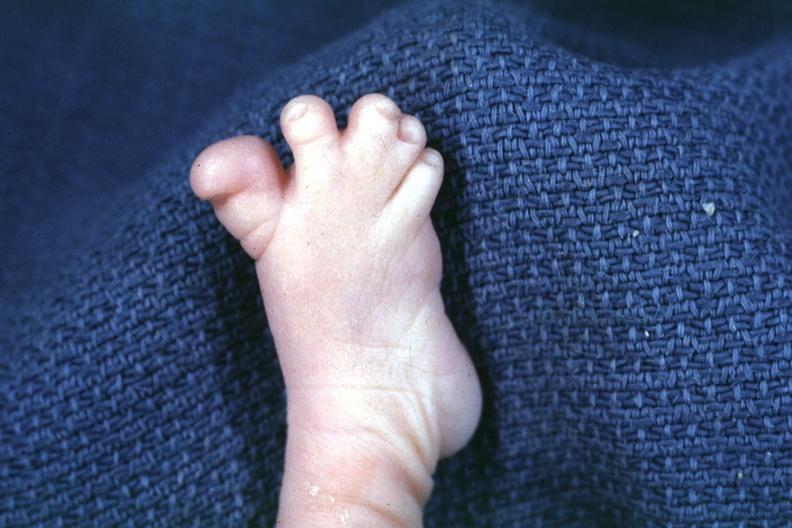re six digits present?
Answer the question using a single word or phrase. No 